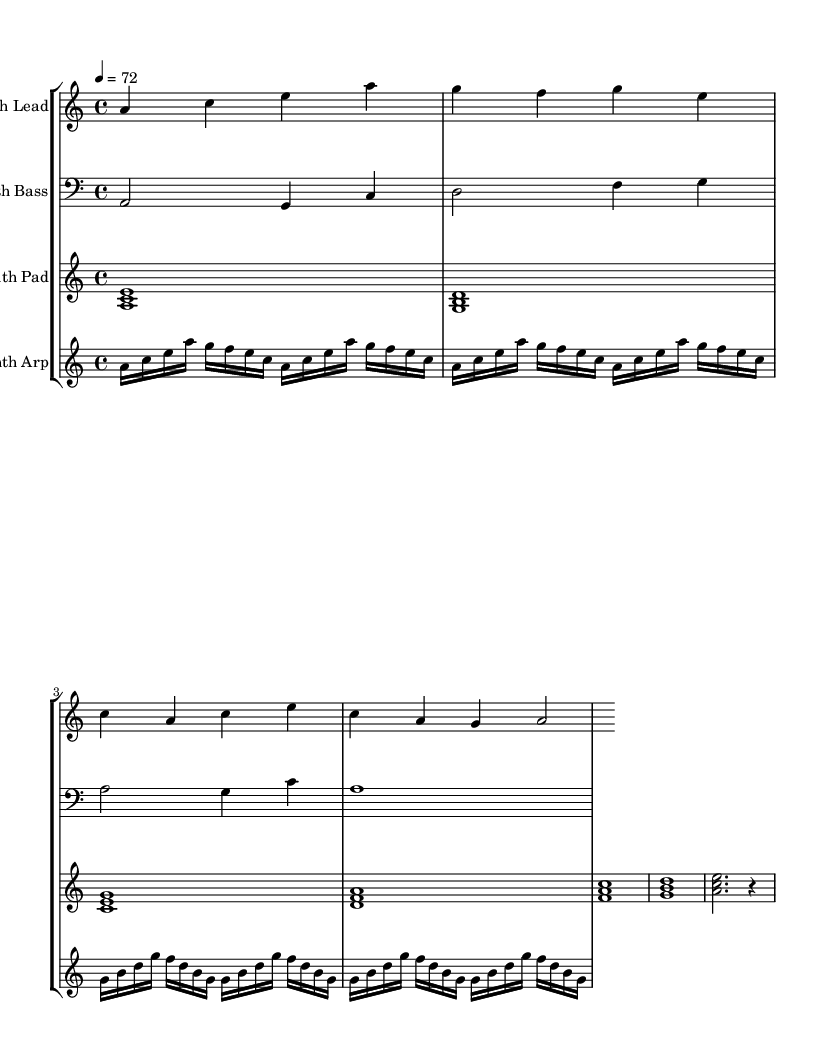What is the key signature of this music? The key signature is A minor, which has no sharps or flats.
Answer: A minor What is the time signature of this music? The time signature is indicated as 4/4, meaning there are four beats in each measure and the quarter note gets one beat.
Answer: 4/4 What is the tempo marking of this piece? The tempo marking is indicated as 4 = 72, meaning that there are 72 beats per minute.
Answer: 72 How many instruments are represented in the score? The score includes four instruments: Synth Lead, Synth Bass, Synth Pad, and Synth Arp.
Answer: Four Which instrument has the highest pitch range? The Synth Lead plays notes that are arranged in the higher pitch range compared to the other instruments.
Answer: Synth Lead Which instrument plays the bass clef? The Synth Bass is written in the bass clef, indicating it plays lower pitches.
Answer: Synth Bass How many arpeggios are repeated in the Synth Arp part? The Synth Arp contains 8 repeated arpeggios, as indicated by the repeat markings.
Answer: Eight 